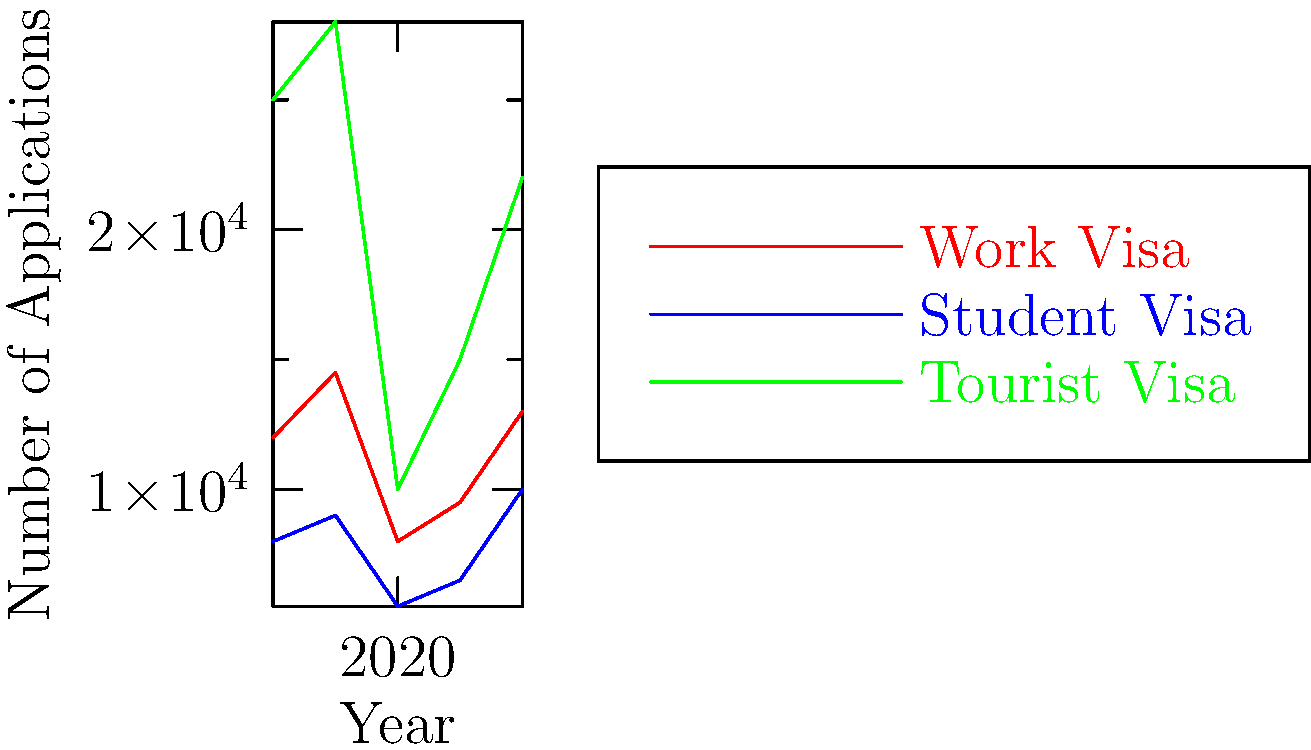Analyze the line graph showing visa application trends from 2018 to 2022. Which visa category experienced the most significant percentage decrease from 2019 to 2020, and what factors specific to South Africa might explain this trend? To answer this question, we need to follow these steps:

1. Calculate the percentage decrease for each visa category from 2019 to 2020:

   Work Visa:
   2019: 14,500
   2020: 8,000
   Percentage decrease = $(14500 - 8000) / 14500 * 100 = 44.8\%$

   Student Visa:
   2019: 9,000
   2020: 5,500
   Percentage decrease = $(9000 - 5500) / 9000 * 100 = 38.9\%$

   Tourist Visa:
   2019: 28,000
   2020: 10,000
   Percentage decrease = $(28000 - 10000) / 28000 * 100 = 64.3\%$

2. Identify the category with the largest percentage decrease:
   Tourist Visa experienced the most significant percentage decrease at 64.3%.

3. Consider factors specific to South Africa that might explain this trend:
   - COVID-19 pandemic: South Africa implemented strict travel restrictions in 2020.
   - Economic impact: The global economic downturn affected tourism worldwide.
   - Health concerns: South Africa reported high COVID-19 cases, deterring tourists.
   - Lockdown measures: Closure of tourist attractions and limitations on gatherings.
   - Travel bans: Many countries imposed travel bans on South Africa due to virus variants.

The tourist visa category was most affected due to the nature of tourism being non-essential compared to work or study purposes.
Answer: Tourist visas (64.3% decrease); COVID-19 pandemic and related restrictions. 